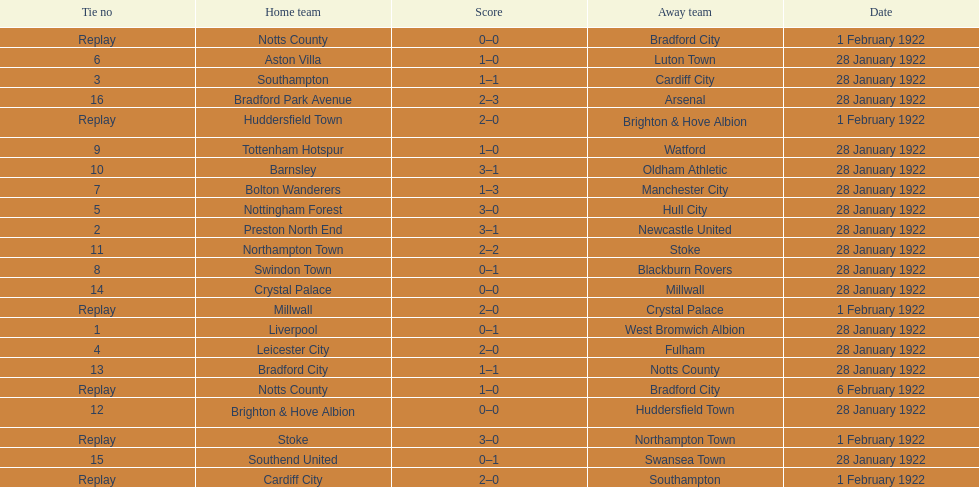How many games had four total points scored or more? 5. Parse the table in full. {'header': ['Tie no', 'Home team', 'Score', 'Away team', 'Date'], 'rows': [['Replay', 'Notts County', '0–0', 'Bradford City', '1 February 1922'], ['6', 'Aston Villa', '1–0', 'Luton Town', '28 January 1922'], ['3', 'Southampton', '1–1', 'Cardiff City', '28 January 1922'], ['16', 'Bradford Park Avenue', '2–3', 'Arsenal', '28 January 1922'], ['Replay', 'Huddersfield Town', '2–0', 'Brighton & Hove Albion', '1 February 1922'], ['9', 'Tottenham Hotspur', '1–0', 'Watford', '28 January 1922'], ['10', 'Barnsley', '3–1', 'Oldham Athletic', '28 January 1922'], ['7', 'Bolton Wanderers', '1–3', 'Manchester City', '28 January 1922'], ['5', 'Nottingham Forest', '3–0', 'Hull City', '28 January 1922'], ['2', 'Preston North End', '3–1', 'Newcastle United', '28 January 1922'], ['11', 'Northampton Town', '2–2', 'Stoke', '28 January 1922'], ['8', 'Swindon Town', '0–1', 'Blackburn Rovers', '28 January 1922'], ['14', 'Crystal Palace', '0–0', 'Millwall', '28 January 1922'], ['Replay', 'Millwall', '2–0', 'Crystal Palace', '1 February 1922'], ['1', 'Liverpool', '0–1', 'West Bromwich Albion', '28 January 1922'], ['4', 'Leicester City', '2–0', 'Fulham', '28 January 1922'], ['13', 'Bradford City', '1–1', 'Notts County', '28 January 1922'], ['Replay', 'Notts County', '1–0', 'Bradford City', '6 February 1922'], ['12', 'Brighton & Hove Albion', '0–0', 'Huddersfield Town', '28 January 1922'], ['Replay', 'Stoke', '3–0', 'Northampton Town', '1 February 1922'], ['15', 'Southend United', '0–1', 'Swansea Town', '28 January 1922'], ['Replay', 'Cardiff City', '2–0', 'Southampton', '1 February 1922']]} 